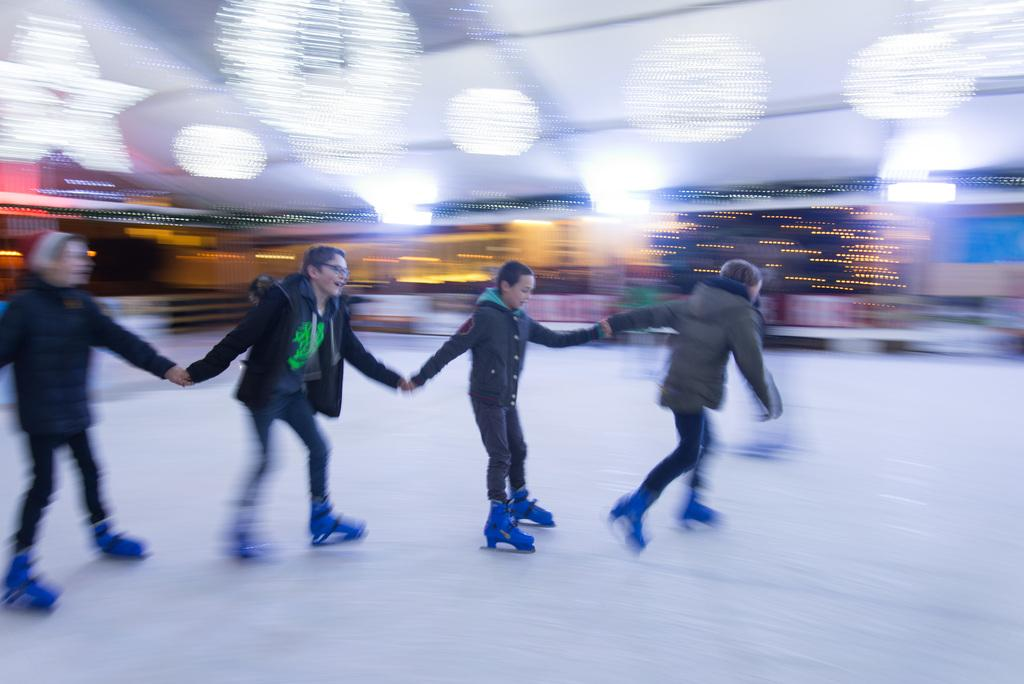What are the people in the image doing? The people in the image are skating. What can be seen beneath the people in the image? The ground is visible in the image. How would you describe the background of the image? The background of the image is blurred. What type of glove is the queen wearing in the image? There is no queen or glove present in the image. 